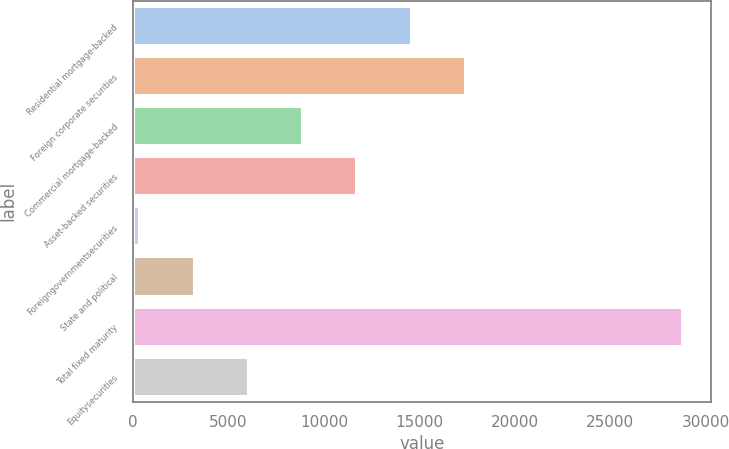Convert chart to OTSL. <chart><loc_0><loc_0><loc_500><loc_500><bar_chart><fcel>Residential mortgage-backed<fcel>Foreign corporate securities<fcel>Commercial mortgage-backed<fcel>Asset-backed securities<fcel>Foreigngovernmentsecurities<fcel>State and political<fcel>Total fixed maturity<fcel>Equitysecurities<nl><fcel>14599<fcel>17443.4<fcel>8910.2<fcel>11754.6<fcel>377<fcel>3221.4<fcel>28821<fcel>6065.8<nl></chart> 